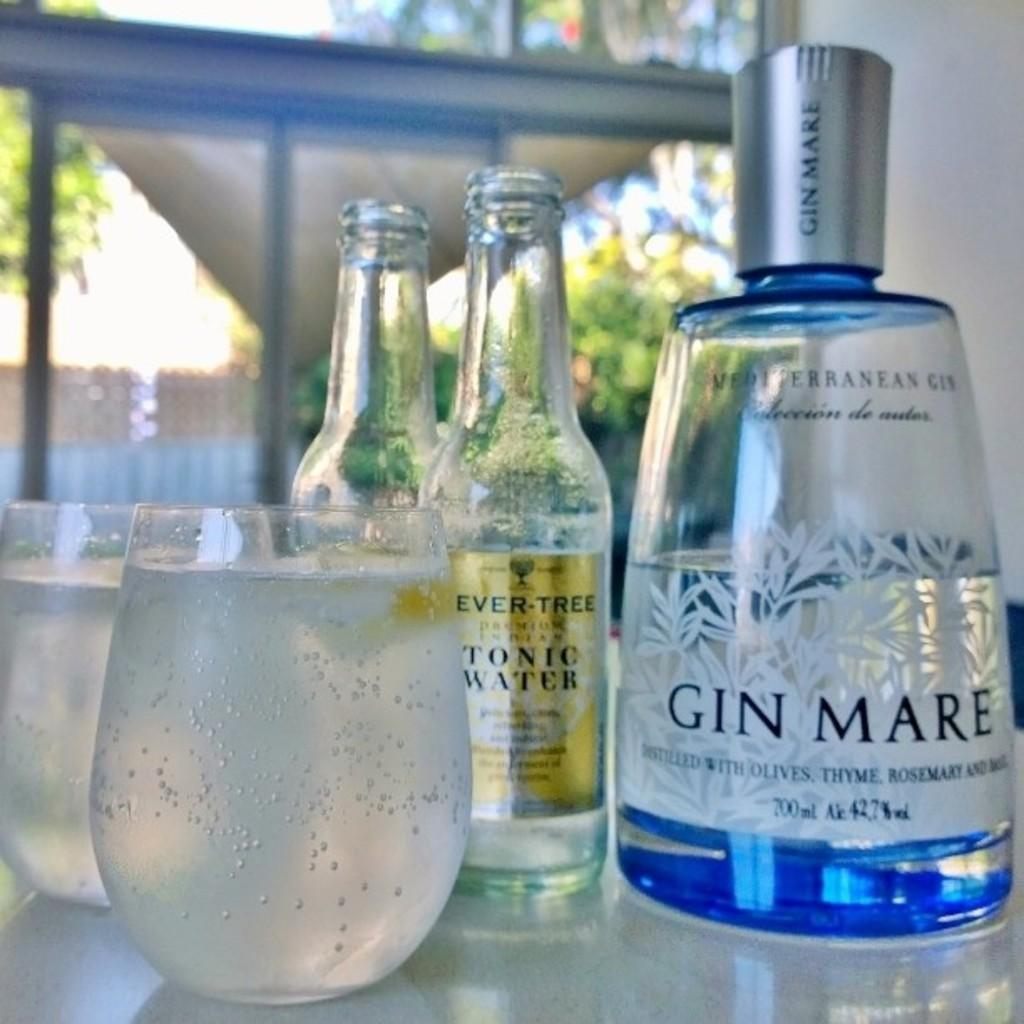<image>
Offer a succinct explanation of the picture presented. the word gin is on the front of the bottle 